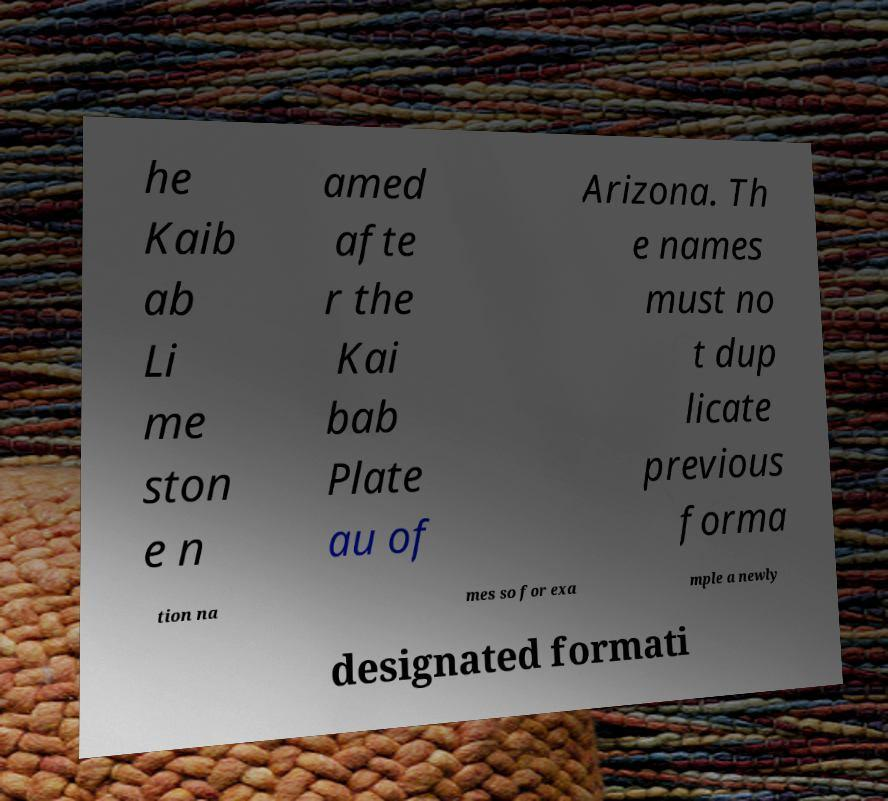Can you accurately transcribe the text from the provided image for me? he Kaib ab Li me ston e n amed afte r the Kai bab Plate au of Arizona. Th e names must no t dup licate previous forma tion na mes so for exa mple a newly designated formati 